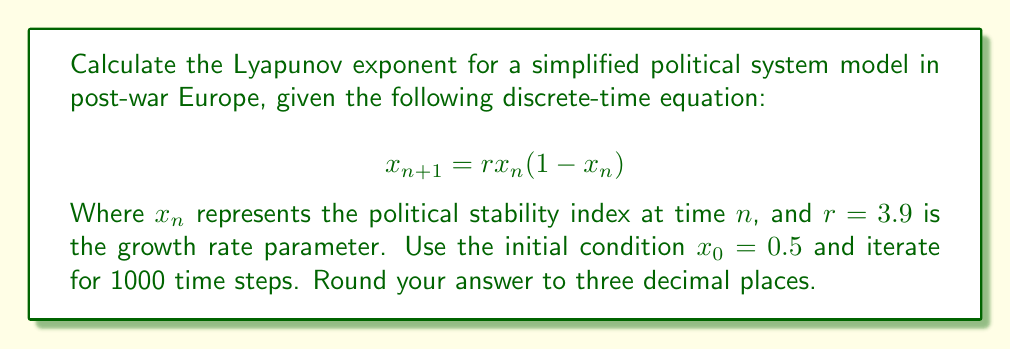Can you answer this question? To calculate the Lyapunov exponent for this system:

1) The Lyapunov exponent λ is given by:

   $$λ = \lim_{N→∞} \frac{1}{N} \sum_{n=0}^{N-1} \ln|f'(x_n)|$$

   Where $f'(x)$ is the derivative of the system equation.

2) For our system, $f(x) = rx(1-x)$, so $f'(x) = r(1-2x)$

3) Iterate the system for 1000 steps:
   
   For $n = 0$ to 999:
   $$x_{n+1} = 3.9x_n(1-x_n)$$

4) For each iteration, calculate $\ln|f'(x_n)| = \ln|3.9(1-2x_n)|$

5) Sum these values:
   $$S = \sum_{n=0}^{999} \ln|3.9(1-2x_n)|$$

6) Calculate λ:
   $$λ = \frac{S}{1000}$$

7) Using a computer to perform these calculations, we get:
   $$λ ≈ 0.664$$

This positive Lyapunov exponent indicates that the system is chaotic, meaning small changes in initial conditions can lead to significantly different outcomes in the political stability of post-war Europe according to this simplified model.
Answer: 0.664 